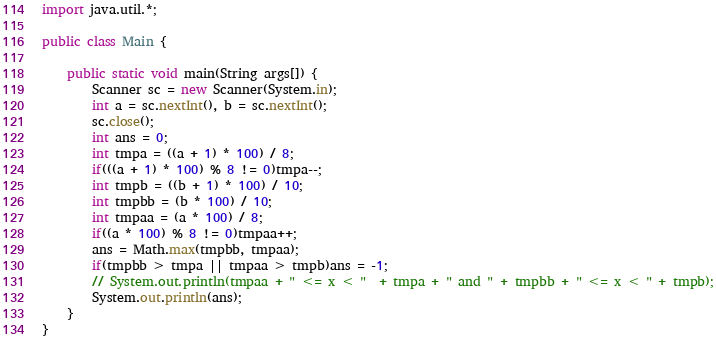<code> <loc_0><loc_0><loc_500><loc_500><_Java_>import java.util.*;

public class Main {

	public static void main(String args[]) {
		Scanner sc = new Scanner(System.in);
		int a = sc.nextInt(), b = sc.nextInt();
		sc.close();
		int ans = 0;
		int tmpa = ((a + 1) * 100) / 8;
		if(((a + 1) * 100) % 8 != 0)tmpa--;
		int tmpb = ((b + 1) * 100) / 10;
		int tmpbb = (b * 100) / 10;
		int tmpaa = (a * 100) / 8;
		if((a * 100) % 8 != 0)tmpaa++;
		ans = Math.max(tmpbb, tmpaa);
		if(tmpbb > tmpa || tmpaa > tmpb)ans = -1;
		// System.out.println(tmpaa + " <= x < "  + tmpa + " and " + tmpbb + " <= x < " + tmpb);
		System.out.println(ans);
	}
}
</code> 